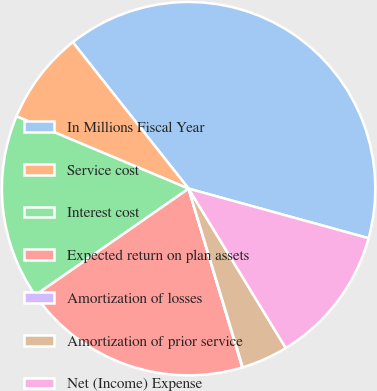<chart> <loc_0><loc_0><loc_500><loc_500><pie_chart><fcel>In Millions Fiscal Year<fcel>Service cost<fcel>Interest cost<fcel>Expected return on plan assets<fcel>Amortization of losses<fcel>Amortization of prior service<fcel>Net (Income) Expense<nl><fcel>39.93%<fcel>8.02%<fcel>16.0%<fcel>19.98%<fcel>0.04%<fcel>4.03%<fcel>12.01%<nl></chart> 